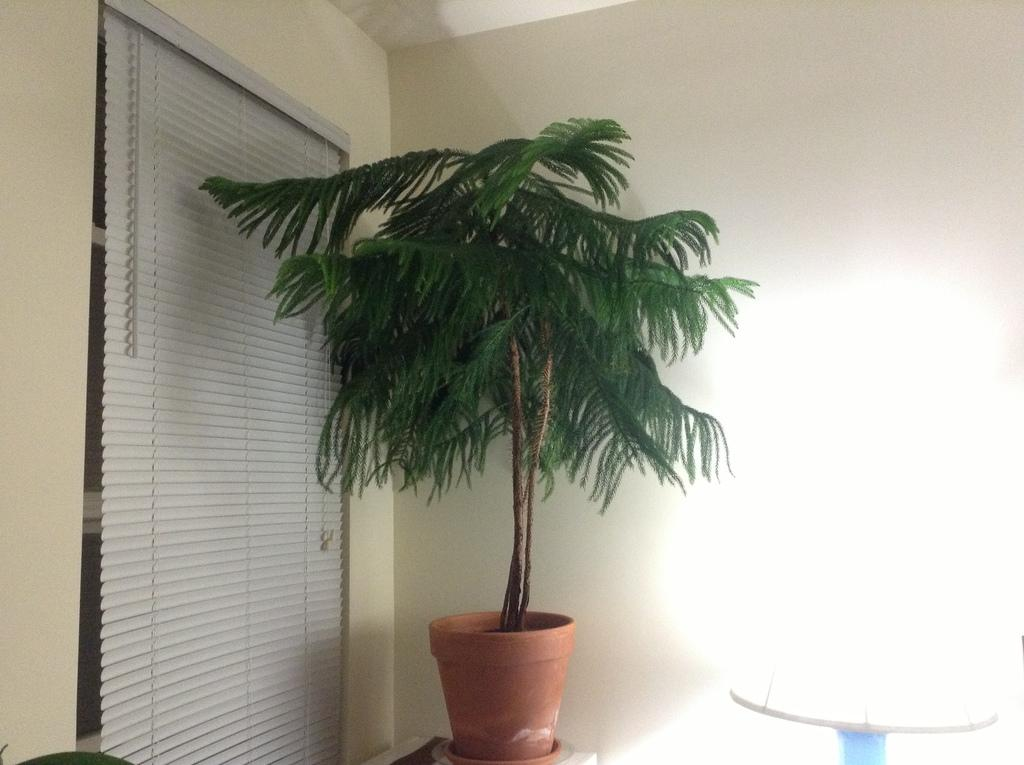What type of object is present in the image that is typically used for growing plants? There is a plant in the image, and it is in a pot. What can be seen near the plant in the image? There is a window with shutters visible near the plant. What is the background of the image made of? There is a wall in the image, which serves as the background. What type of lighting is present in the image? There is a lamp in the image, which provides lighting. What type of pollution can be seen coming from the cart in the image? There is no cart present in the image, and therefore no pollution can be observed. 